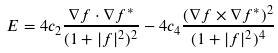Convert formula to latex. <formula><loc_0><loc_0><loc_500><loc_500>E = 4 c _ { 2 } \frac { \nabla f \cdot \nabla f ^ { * } } { ( 1 + | f | ^ { 2 } ) ^ { 2 } } - 4 c _ { 4 } \frac { ( \nabla f \times \nabla f ^ { * } ) ^ { 2 } } { ( 1 + | f | ^ { 2 } ) ^ { 4 } }</formula> 